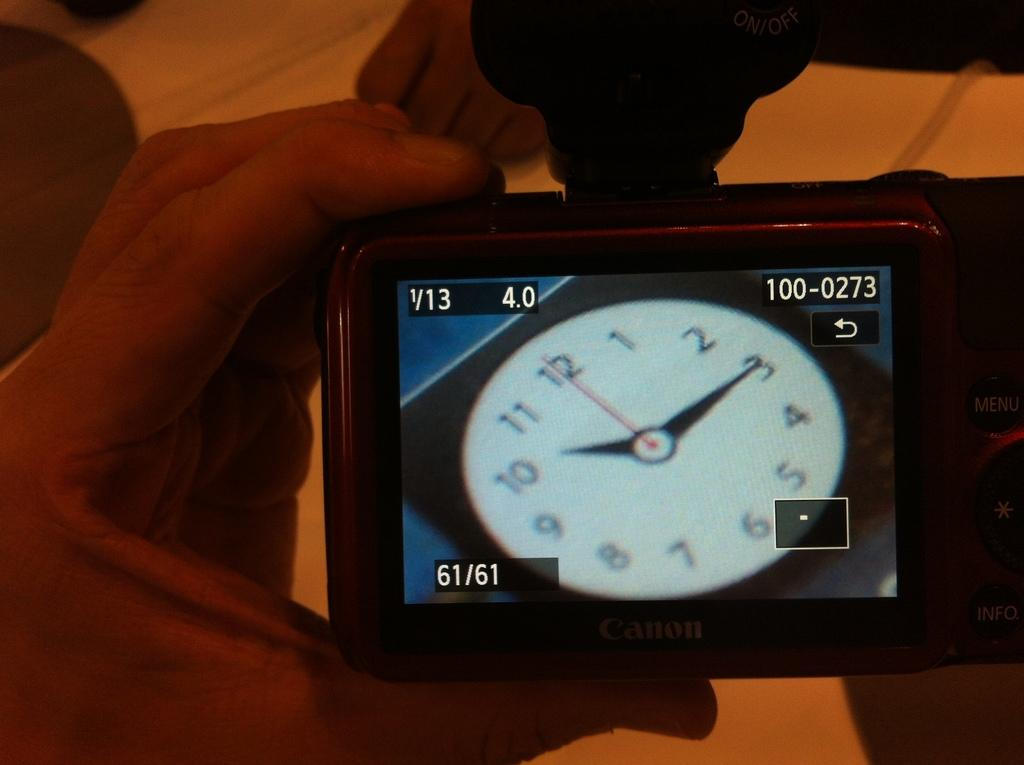<image>
Share a concise interpretation of the image provided. A screen displays a clock that shows a time of ten fifteen. 